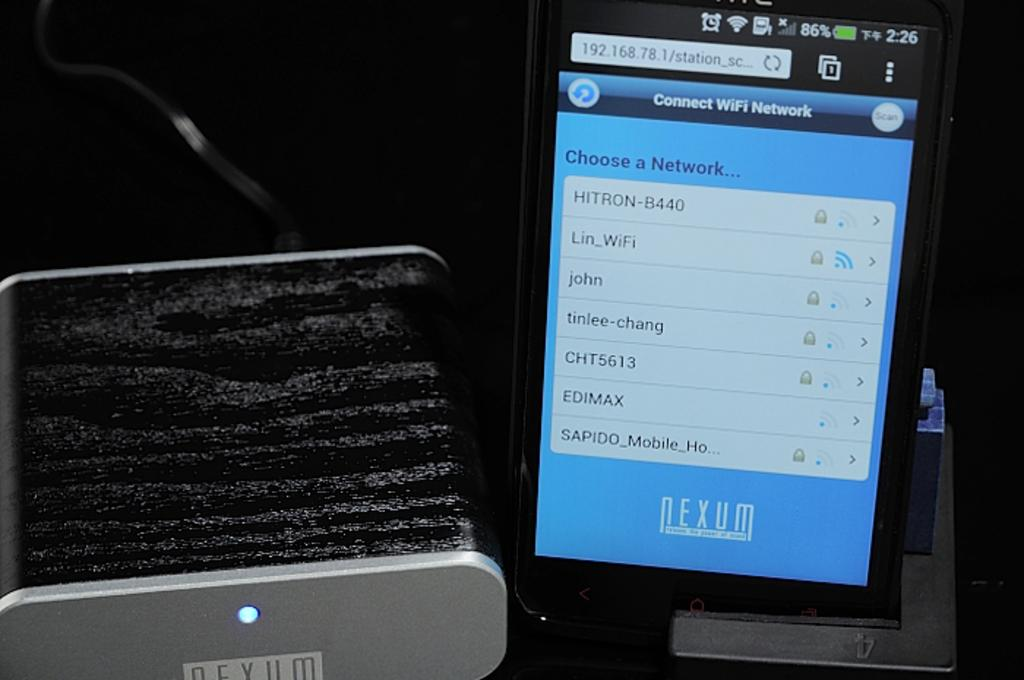<image>
Write a terse but informative summary of the picture. Among the networks the user can choose is one called tinlee-chang. 